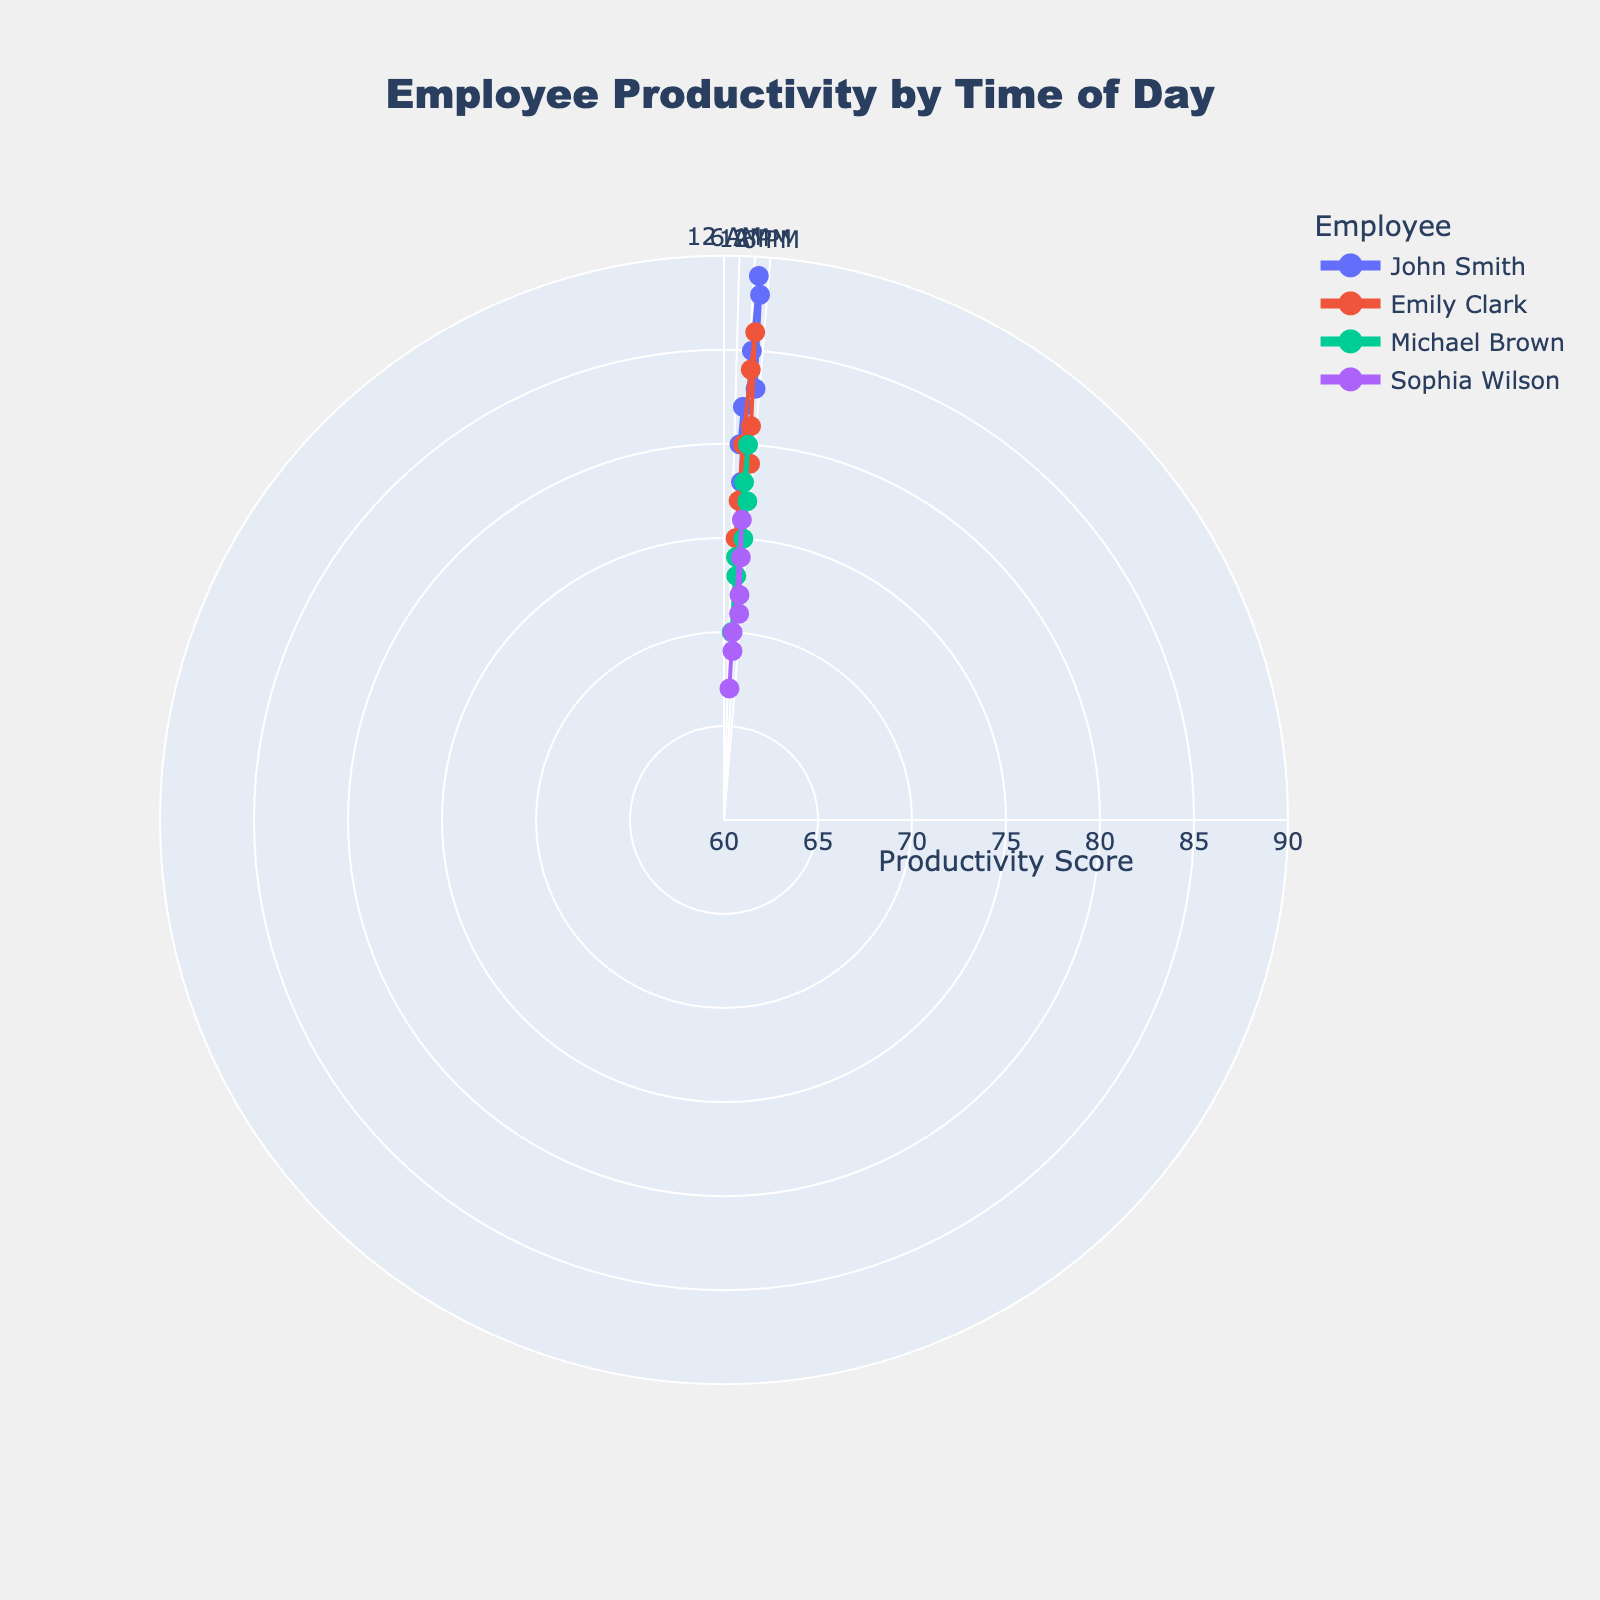What's the title of the plot? The title of the plot is displayed prominently at the top of the figure. Upon viewing, it reads "Employee Productivity by Time of Day".
Answer: Employee Productivity by Time of Day Which employee has the highest productivity score at 2 PM? To find the highest productivity score at 2 PM, locate the data points corresponding to 2 PM (14:00) on the radial axis and compare their scores. John Smith has a productivity score of 89 at 2 PM.
Answer: John Smith How does Emily Clark's productivity change over the day? To determine how Emily Clark's productivity changes, observe the line plot for Emily. Starting from 9 AM, her score goes from 75 to a peak of 86 at 2 PM, then decreases to 79 by 4 PM.
Answer: Increases from 75 at 9 AM to 86 at 2 PM, then decreases to 79 by 4 PM What is the average productivity score for Michael Brown? To calculate the average score for Michael Brown, sum his scores and divide by the number of hours: (70 + 74 + 73 + 78 + 80 + 75 + 77) / 7 = 527/7. The average is approximately 75.29.
Answer: Approximately 75.29 Which department has the highest overall productivity score at any time? Compare the highest productivity scores for data points from each department. John Smith from Data Entry Department has the highest overall productivity score of 89 at 2 PM, thus the Data Entry Department has the highest score.
Answer: Data Entry Who shows the most consistent productivity throughout the day? To determine consistency, observe the variations in the productivity scores. John Smith's productivity varies between 78 and 89, while Emily Clark's varies between 75 and 86. Michael Brown's scores range from 70 to 80, and Sophia Wilson's range from 67 to 76. Sophia Wilson shows scores within a smaller range, indicating the most consistency.
Answer: Sophia Wilson At what time does the lowest productivity score occur, and who has it? Locate the lowest point on the radial axis and find which employee it represents at which time. Sophia Wilson has the lowest productivity score of 67 at 9 AM.
Answer: Sophia Wilson at 9 AM Does any employee improve in productivity towards the end of the day? Look for upward trends towards the end of the day. John Smith's productivity decreases towards the end, Emily Clark's also decreases, while Michael Brown shows a slight improvement from a dip at 3 PM to a higher score at 4 PM.
Answer: Michael Brown What hour of the day shows the highest average productivity score across all employees? To determine this, average the productivity scores for each hour across all employees:
- 9 AM: (80 + 75 + 70 + 67) / 4 = 73
- 10 AM: (82 + 77 + 74 + 70) / 4 = 75.75
- 11 AM: (78 + 80 + 73 + 69) / 4 = 75
- 1 PM: (85 + 84 + 78 + 76) / 4 = 80.75
- 2 PM: (89 + 86 + 80 + 74) / 4 = 82.25
- 3 PM: (88 + 81 + 75 + 72) / 4 = 79
- 4 PM: (83 + 79 + 77 + 71) / 4 = 77.5
2 PM has the highest average score of 82.25.
Answer: 2 PM 